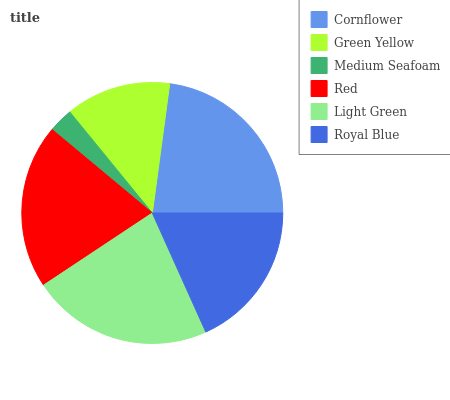Is Medium Seafoam the minimum?
Answer yes or no. Yes. Is Cornflower the maximum?
Answer yes or no. Yes. Is Green Yellow the minimum?
Answer yes or no. No. Is Green Yellow the maximum?
Answer yes or no. No. Is Cornflower greater than Green Yellow?
Answer yes or no. Yes. Is Green Yellow less than Cornflower?
Answer yes or no. Yes. Is Green Yellow greater than Cornflower?
Answer yes or no. No. Is Cornflower less than Green Yellow?
Answer yes or no. No. Is Red the high median?
Answer yes or no. Yes. Is Royal Blue the low median?
Answer yes or no. Yes. Is Medium Seafoam the high median?
Answer yes or no. No. Is Red the low median?
Answer yes or no. No. 